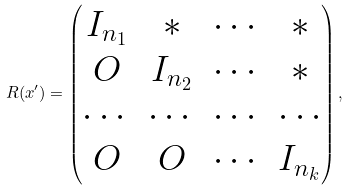Convert formula to latex. <formula><loc_0><loc_0><loc_500><loc_500>R ( x ^ { \prime } ) = \begin{pmatrix} I _ { n _ { 1 } } & * & \cdots & * \\ O & I _ { n _ { 2 } } & \cdots & * \\ \cdots & \cdots & \cdots & \cdots \\ O & O & \cdots & I _ { n _ { k } } \end{pmatrix} ,</formula> 